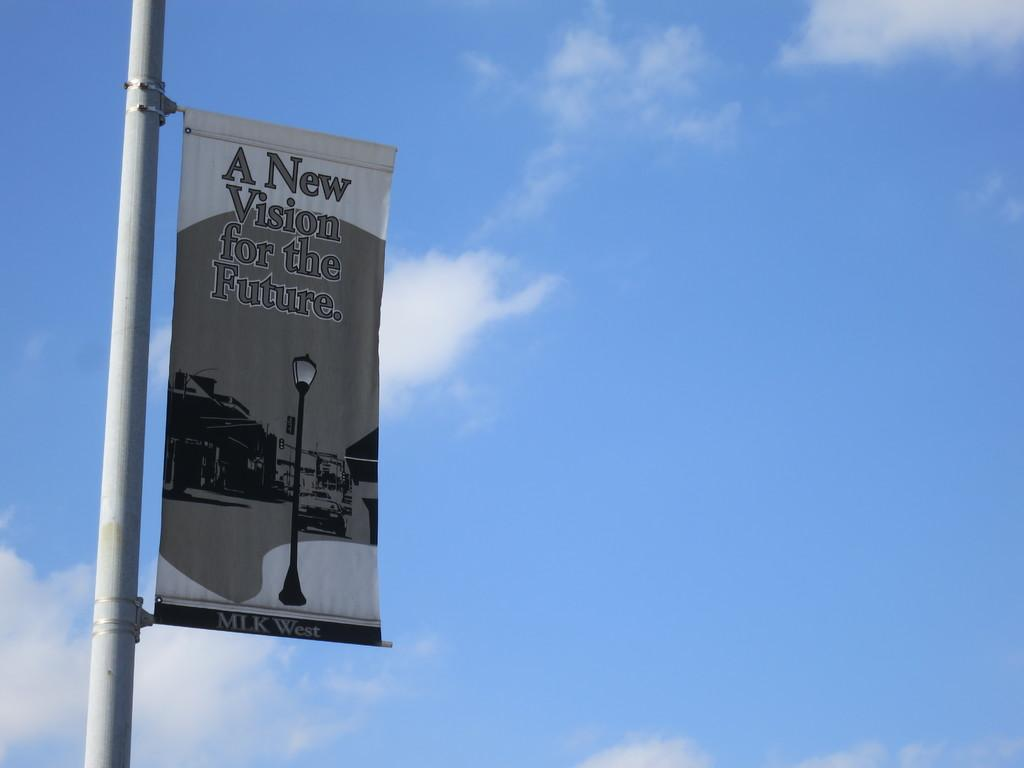<image>
Summarize the visual content of the image. A pole with a flag saying a new vision for the future 